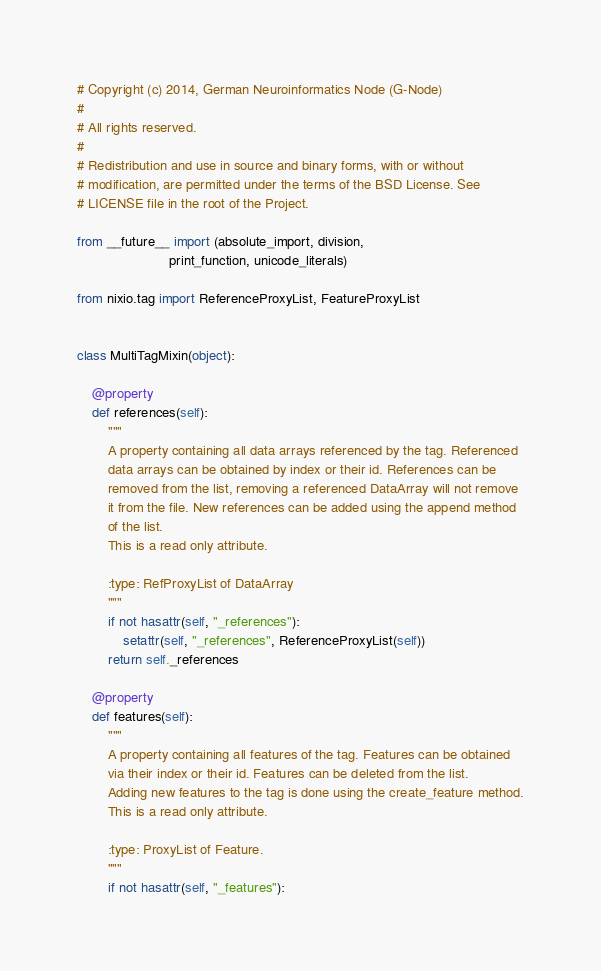<code> <loc_0><loc_0><loc_500><loc_500><_Python_># Copyright (c) 2014, German Neuroinformatics Node (G-Node)
#
# All rights reserved.
#
# Redistribution and use in source and binary forms, with or without
# modification, are permitted under the terms of the BSD License. See
# LICENSE file in the root of the Project.

from __future__ import (absolute_import, division,
                        print_function, unicode_literals)

from nixio.tag import ReferenceProxyList, FeatureProxyList


class MultiTagMixin(object):

    @property
    def references(self):
        """
        A property containing all data arrays referenced by the tag. Referenced
        data arrays can be obtained by index or their id. References can be
        removed from the list, removing a referenced DataArray will not remove
        it from the file. New references can be added using the append method
        of the list.
        This is a read only attribute.

        :type: RefProxyList of DataArray
        """
        if not hasattr(self, "_references"):
            setattr(self, "_references", ReferenceProxyList(self))
        return self._references

    @property
    def features(self):
        """
        A property containing all features of the tag. Features can be obtained
        via their index or their id. Features can be deleted from the list.
        Adding new features to the tag is done using the create_feature method.
        This is a read only attribute.

        :type: ProxyList of Feature.
        """
        if not hasattr(self, "_features"):</code> 